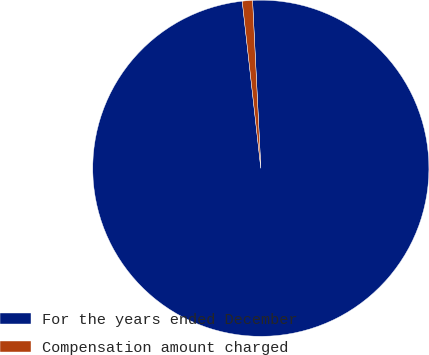Convert chart. <chart><loc_0><loc_0><loc_500><loc_500><pie_chart><fcel>For the years ended December<fcel>Compensation amount charged<nl><fcel>99.02%<fcel>0.98%<nl></chart> 